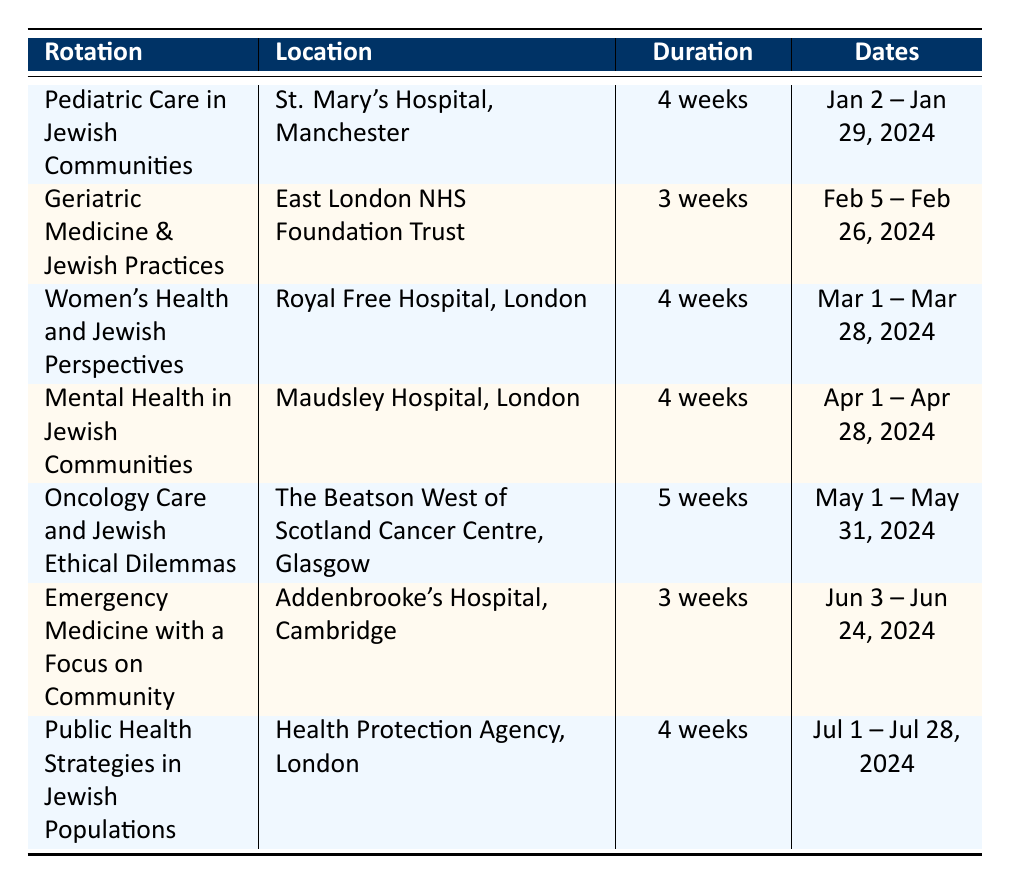What is the location for the rotation "Women's Health and Jewish Perspectives"? The table indicates that "Women's Health and Jewish Perspectives" takes place at the Royal Free Hospital in London.
Answer: Royal Free Hospital, London How many weeks is the rotation "Geriatric Medicine & Jewish Practices"? According to the table, the duration of the "Geriatric Medicine & Jewish Practices" rotation is 3 weeks.
Answer: 3 weeks Which rotation has the longest duration? The table shows that "Oncology Care and Jewish Ethical Dilemmas" lasts 5 weeks, which is longer than all other rotations; thus, it has the longest duration.
Answer: Oncology Care and Jewish Ethical Dilemmas Is the focus area for "Mental Health in Jewish Communities" related to elderly patients? The focus area for "Mental Health in Jewish Communities" pertains to cultural stigma and therapy approaches primarily for adolescents, which is not directly related to elderly patients.
Answer: No What is the total duration of all rotations combined? To find the total duration, sum the durations of all the rotations: 4 + 3 + 4 + 4 + 5 + 3 + 4 = 27 weeks. Therefore, the total is 27 weeks.
Answer: 27 weeks Which supervisor oversees the "Oncology Care and Jewish Ethical Dilemmas" rotation? The table lists Dr. Miriam Katz as the supervisor for the "Oncology Care and Jewish Ethical Dilemmas" rotation.
Answer: Dr. Miriam Katz During which month does the "Emergency Medicine with a Focus on Community" rotation take place? The "Emergency Medicine with a Focus on Community" rotation starts on June 3, 2024, and ends on June 24, 2024, thus taking place in June.
Answer: June Which rotation focuses on addressing unique needs of Jewish women? The rotation titled "Women's Health and Jewish Perspectives" is specifically focused on addressing the unique needs of Jewish women, resulting in a culturally informed approach.
Answer: Women's Health and Jewish Perspectives Compare the number of rotations that focus on child health and elderly care. The "Pediatric Care in Jewish Communities" rotation focuses on child health, while the "Geriatric Medicine & Jewish Practices" emphasizes elderly care. There are 1 rotation for each focus area, making them equal.
Answer: 1 each 